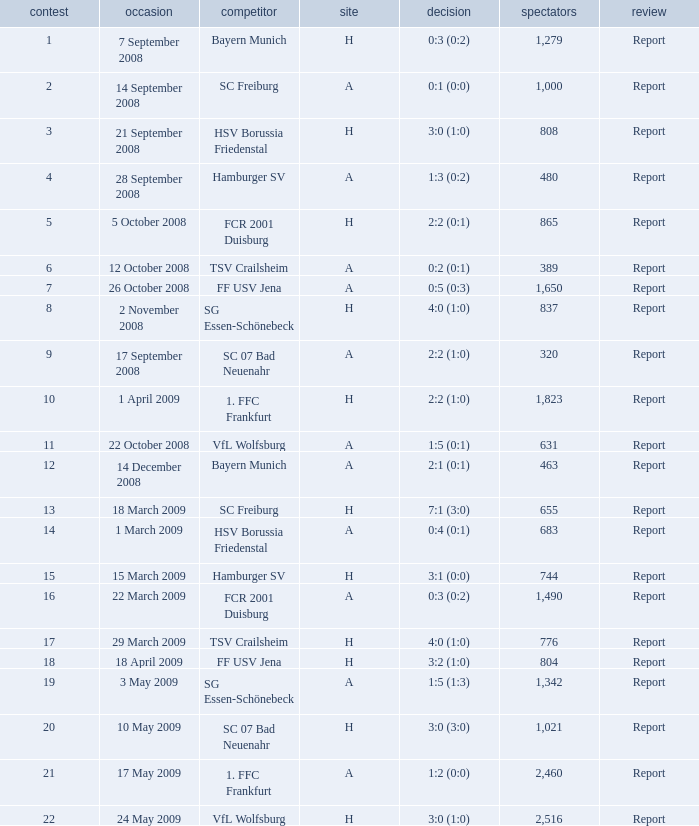Which match had more than 1,490 people in attendance to watch FCR 2001 Duisburg have a result of 0:3 (0:2)? None. 